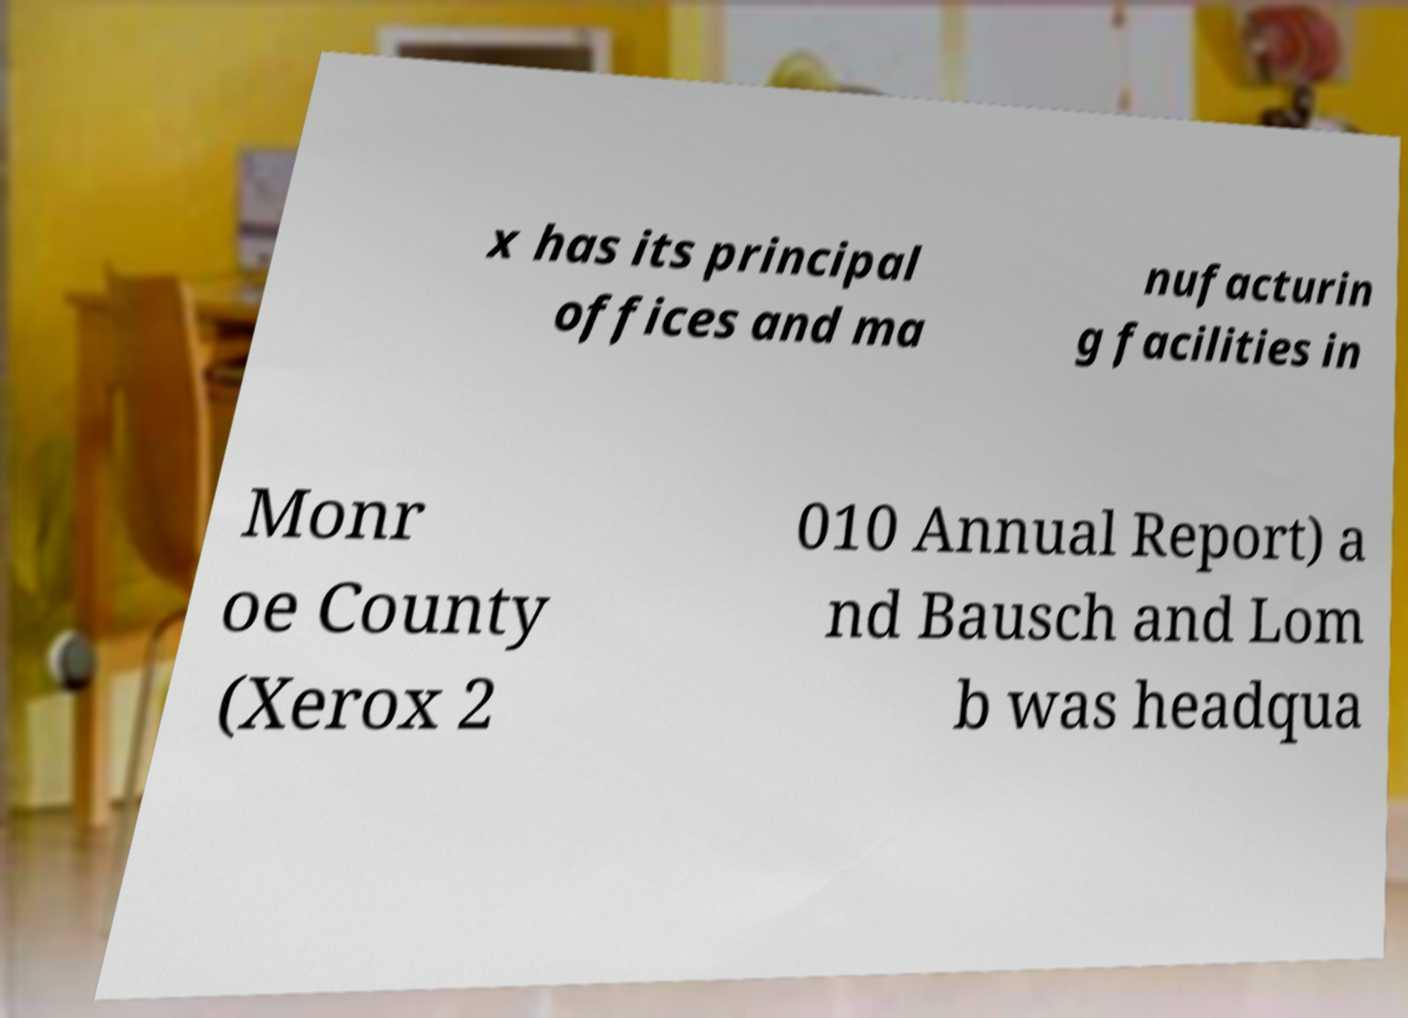What messages or text are displayed in this image? I need them in a readable, typed format. x has its principal offices and ma nufacturin g facilities in Monr oe County (Xerox 2 010 Annual Report) a nd Bausch and Lom b was headqua 